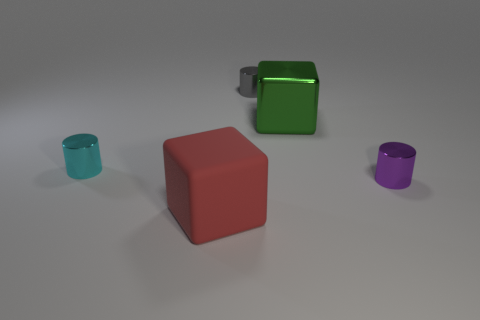What number of cylinders have the same material as the red object?
Provide a succinct answer. 0. Is the gray metallic cylinder the same size as the cyan cylinder?
Offer a very short reply. Yes. Is there anything else of the same color as the large metal block?
Provide a short and direct response. No. What is the shape of the small shiny thing that is both on the right side of the red matte block and in front of the small gray thing?
Your response must be concise. Cylinder. There is a metal thing that is on the left side of the rubber thing; what size is it?
Your answer should be very brief. Small. How many cyan metallic things are in front of the thing that is on the right side of the large block behind the tiny purple metallic cylinder?
Offer a very short reply. 0. There is a green cube; are there any red matte objects behind it?
Provide a succinct answer. No. How many other things are there of the same size as the cyan metallic cylinder?
Your response must be concise. 2. What material is the thing that is both left of the gray cylinder and to the right of the small cyan shiny object?
Provide a short and direct response. Rubber. Do the big thing that is behind the red rubber block and the large thing that is in front of the purple shiny object have the same shape?
Your answer should be compact. Yes. 